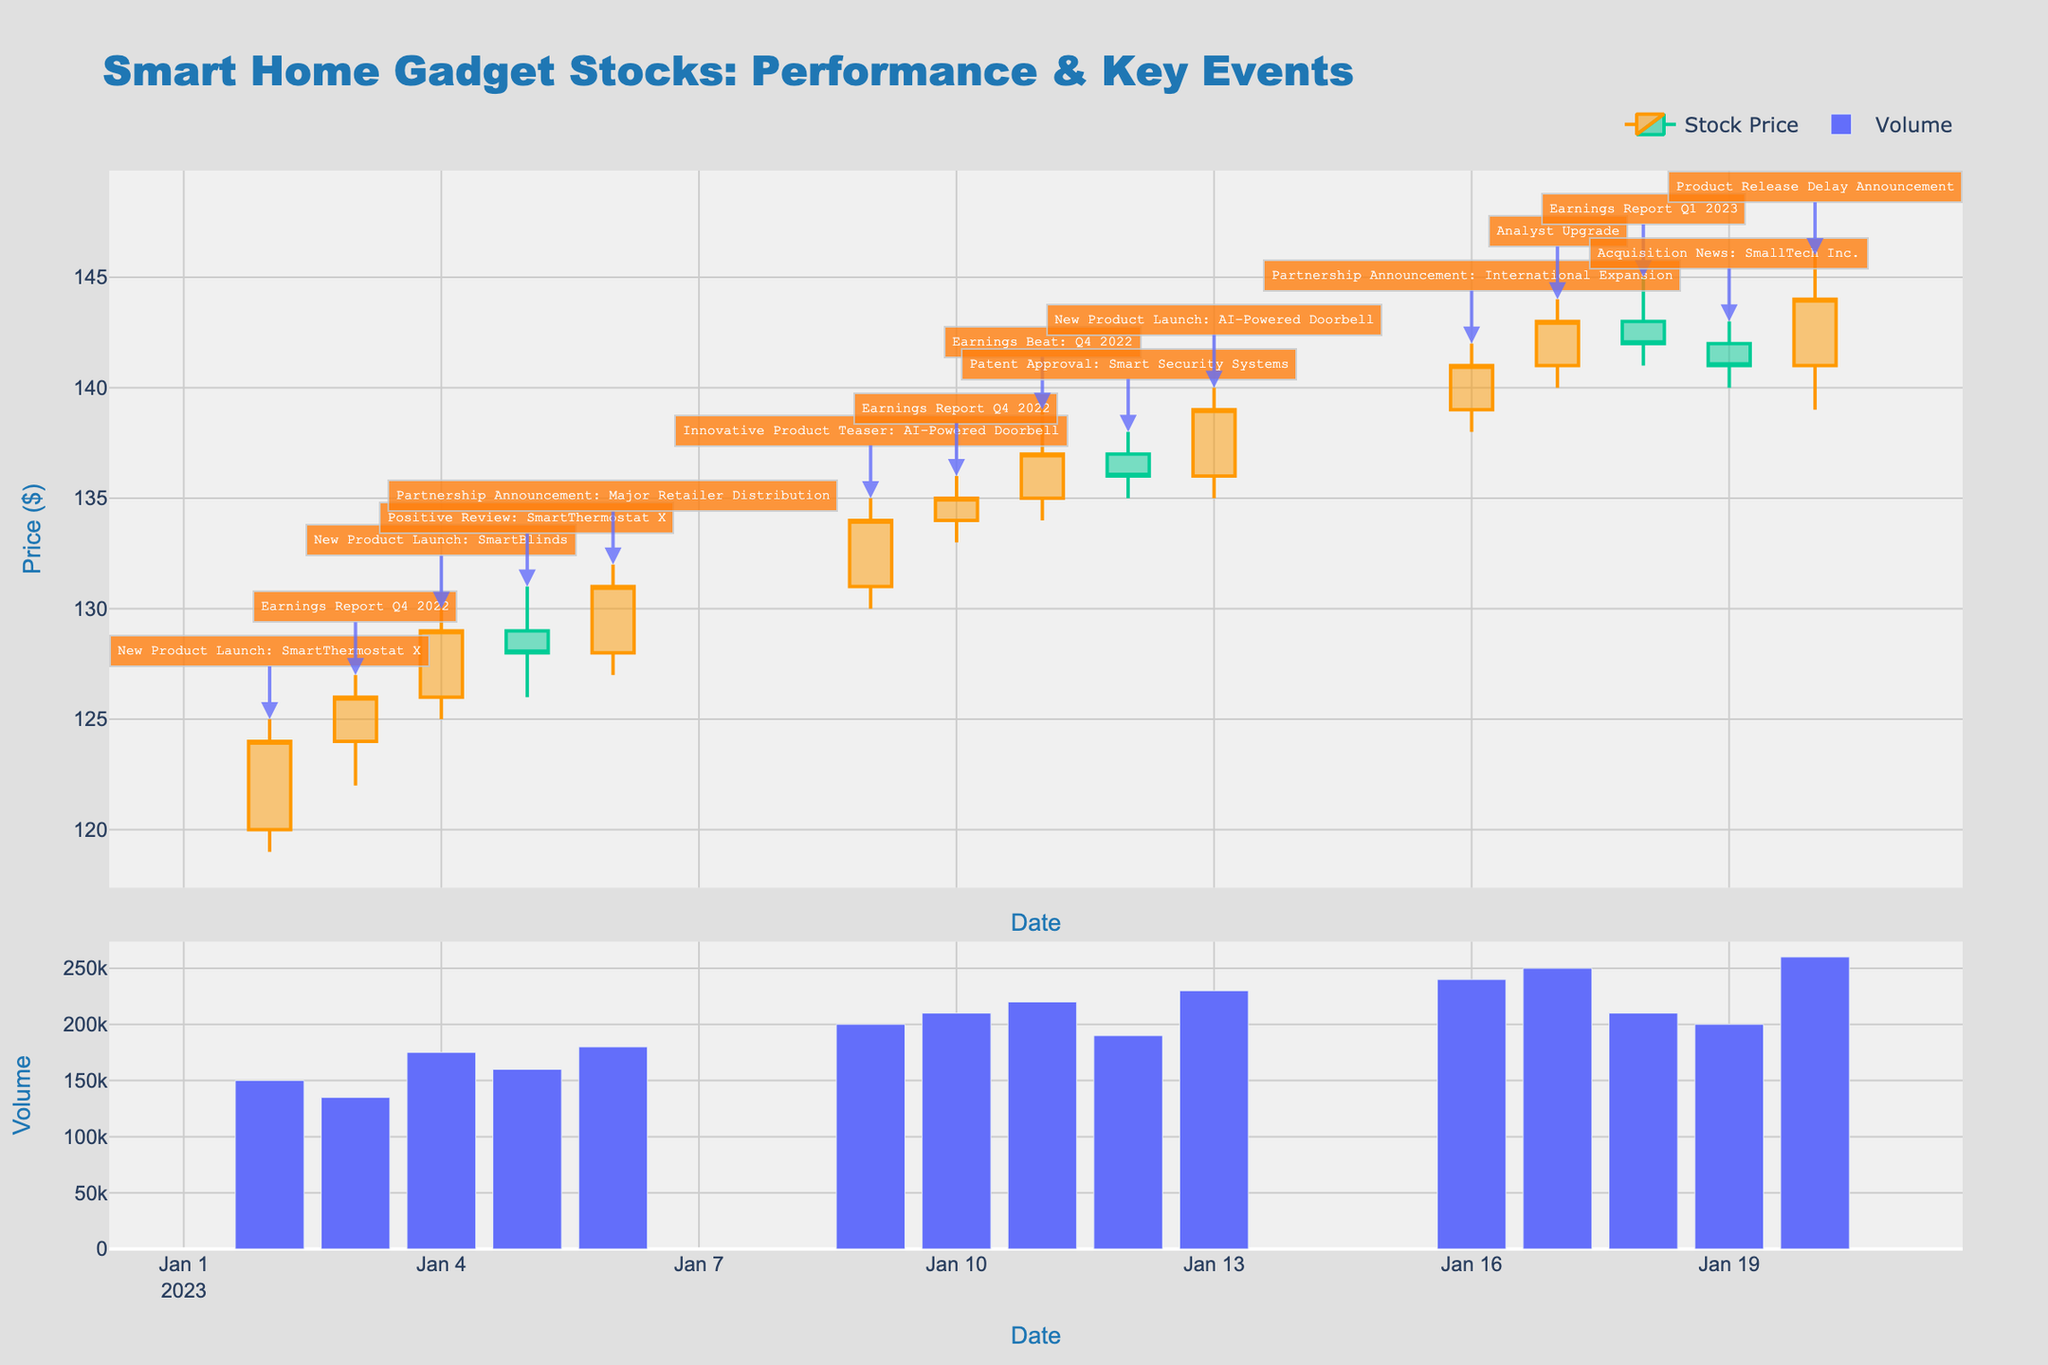What is the title of the figure? The title of the figure is typically found at the top of the chart. In this case, it reads "Smart Home Gadget Stocks: Performance & Key Events."
Answer: Smart Home Gadget Stocks: Performance & Key Events How many data points are displayed in the candlestick plot? Each row in the data corresponds to a single candlestick representing a trading day. By counting the rows, there are 14 trading days displayed.
Answer: 14 On which date did GlobeGadgets announce a partnership for international expansion, and what was the closing stock price on that day? The announcement details can be found in the annotations and the corresponding date can be traced to the candlestick below the annotation. The stock price details for that date, including the close price, are available in the figure.
Answer: 2023-01-16, $141 Which company's stock showed the highest trading volume, on which date, and what was the event? The volume bar chart displays trading volumes for each date. The highest volume bar should be identified, and the corresponding date and event can be traced using the annotations.
Answer: FutureHome, 2023-01-20, Product Release Delay Announcement Compare the closing prices on Jan 11 (when AbleSmart reported an earnings beat) and Jan 9 (when FutureHome teased an innovative product). Which day had a higher closing price? The closing prices can be directly read from the candlestick bars for the respective dates.
Answer: Jan 11 had a higher closing price During which event did the stock price have the largest difference between the high and low prices in a single day, and what was that difference? The difference can be calculated by examining each candlestick bar and inspecting the annotations for significant events. The high and low prices give the range, and the largest can be identified through comparison.
Answer: SecureHome, Partnership Announcement, $5 (132 - 127) What's the median of the closing prices shown in the figure? To find the median, list all closing prices, sort them in ascending order, and find the middle value (or the average of the two middle values if the count is even).
Answer: $136 What was the general trend observable in SecureHome stock prices following the Q4 2022 earnings report? Observing the candlestick bars before and after the Q4 2022 earnings report announcement on Jan 3, one can deduce the trend based on the closing prices.
Answer: Upward trend Which company's stock experienced an upward movement following an earnings report, and what was the effect on the closing price? This can be inferred by identifying the candlestick bars corresponding to earning report events and examining the change in closing prices immediately following the earnings report.
Answer: AbleSmart, Price increased from $135 to $137 Which event had the lowest trading volume and how much was it? By examining the volume bar chart, locate the shortest bar and reference the corresponding date and event annotation.
Answer: SecureHome, Earnings Report Q4 2022, 135,000 